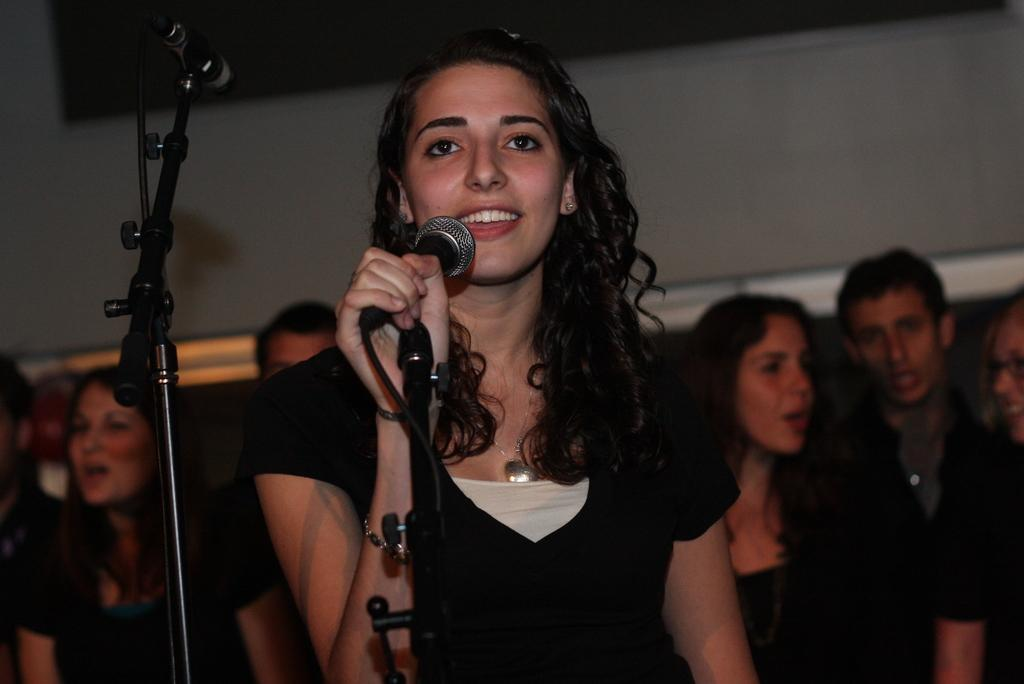What is the woman wearing in the image? The woman is wearing a black dress in the image. What is the woman holding in the image? The woman is holding a microphone in the image. What is the woman's facial expression in the image? The woman is smiling in the image. What is the purpose of the mic holder in the image? The mic holder is used to hold the microphone when not in use. Can you describe the people in the background of the image? There are people in the background of the image, but their specific features cannot be determined from the provided facts. What place does the woman hate the most in the image? There is no information about the woman's feelings or preferences towards any place in the image. 